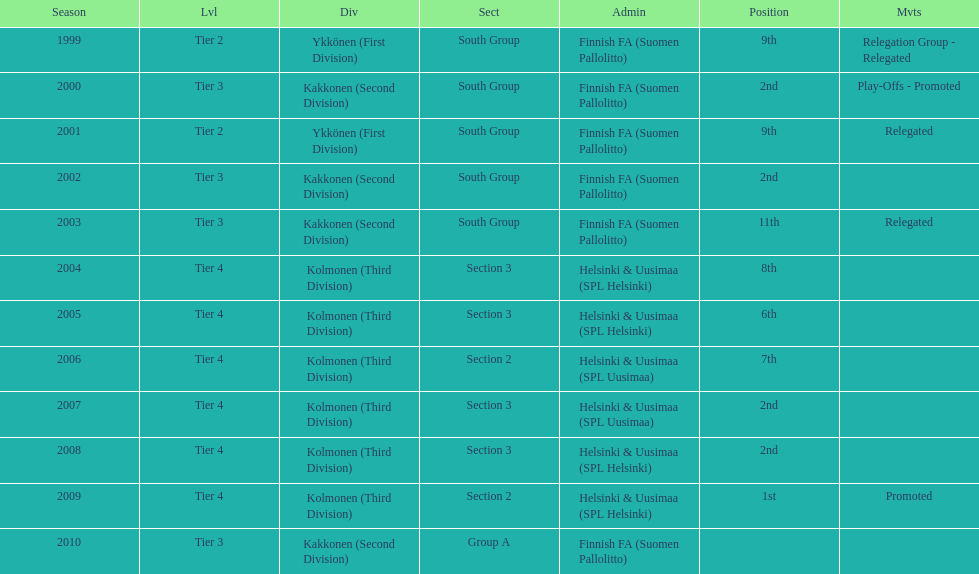How many 2nd positions were there? 4. 